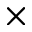<formula> <loc_0><loc_0><loc_500><loc_500>\times</formula> 